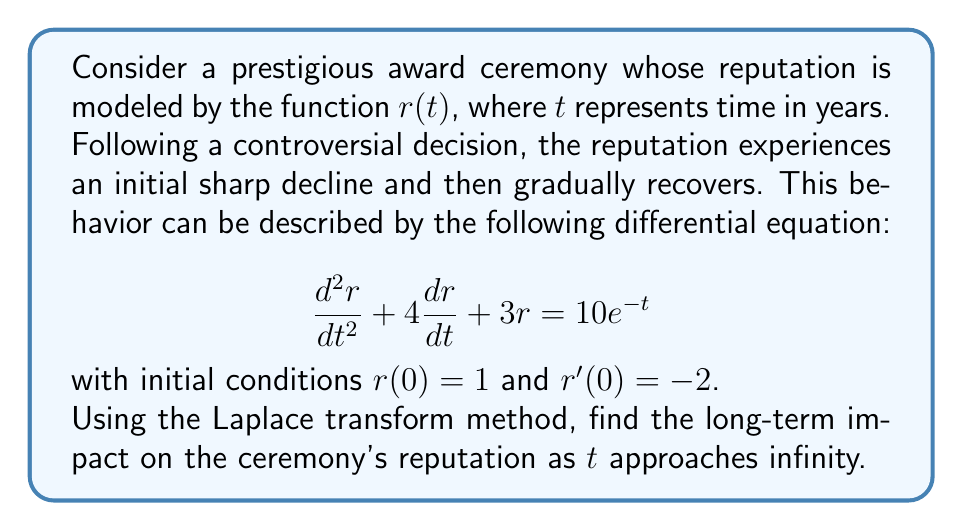Teach me how to tackle this problem. To solve this problem using the Laplace transform method, we'll follow these steps:

1) Take the Laplace transform of both sides of the differential equation:
   $$\mathcal{L}\{r''(t) + 4r'(t) + 3r(t)\} = \mathcal{L}\{10e^{-t}\}$$

2) Using Laplace transform properties:
   $$(s^2R(s) - sr(0) - r'(0)) + 4(sR(s) - r(0)) + 3R(s) = \frac{10}{s+1}$$
   
   Where $R(s) = \mathcal{L}\{r(t)\}$

3) Substitute the initial conditions $r(0) = 1$ and $r'(0) = -2$:
   $$(s^2R(s) - s + 2) + 4(sR(s) - 1) + 3R(s) = \frac{10}{s+1}$$

4) Simplify:
   $$s^2R(s) + 4sR(s) + 3R(s) - s + 2 - 4 = \frac{10}{s+1}$$
   $$(s^2 + 4s + 3)R(s) = \frac{10}{s+1} + s - 2$$

5) Solve for $R(s)$:
   $$R(s) = \frac{10}{(s+1)(s^2 + 4s + 3)} + \frac{s-2}{s^2 + 4s + 3}$$

6) Use partial fraction decomposition:
   $$R(s) = \frac{A}{s+1} + \frac{Bs+C}{s^2 + 4s + 3}$$
   
   Where $A = 1$, $B = 0$, and $C = -1$

7) Take the inverse Laplace transform:
   $$r(t) = e^{-t} - \frac{1}{3}e^{-3t}\cos(\sqrt{2}t) + \frac{1}{\sqrt{2}}e^{-3t}\sin(\sqrt{2}t)$$

8) To find the long-term impact, we take the limit as $t$ approaches infinity:
   $$\lim_{t \to \infty} r(t) = \lim_{t \to \infty} (e^{-t} - \frac{1}{3}e^{-3t}\cos(\sqrt{2}t) + \frac{1}{\sqrt{2}}e^{-3t}\sin(\sqrt{2}t))$$

   As $t$ approaches infinity, all exponential terms approach zero, so:
   $$\lim_{t \to \infty} r(t) = 0$$
Answer: The long-term impact on the ceremony's reputation as $t$ approaches infinity is 0, indicating that the reputation eventually recovers and stabilizes. 